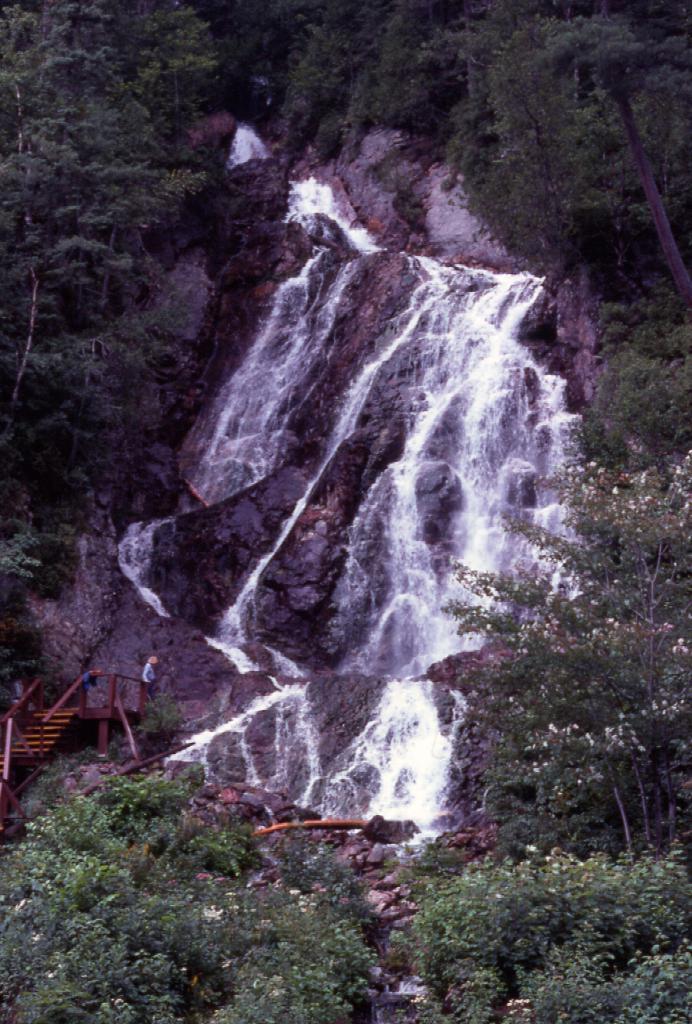Please provide a concise description of this image. In the image there is a waterfall in the middle with trees on either side of it, on the left side it seems to be a person standing on the bridge. 